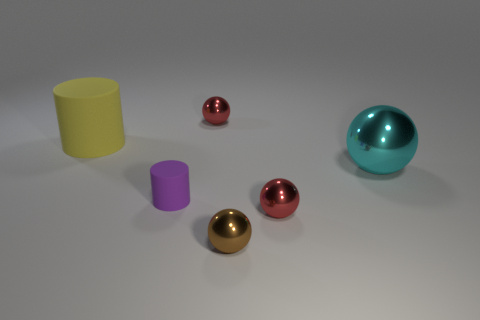How many yellow cylinders are the same size as the brown metal sphere?
Give a very brief answer. 0. There is a big thing that is on the right side of the small cylinder; does it have the same color as the small cylinder?
Ensure brevity in your answer.  No. What is the ball that is in front of the tiny rubber cylinder and on the right side of the small brown sphere made of?
Keep it short and to the point. Metal. Are there more cyan metal things than tiny metal things?
Make the answer very short. No. What is the color of the big object that is left of the tiny thing that is to the left of the tiny object that is behind the big cyan sphere?
Offer a terse response. Yellow. Does the small object behind the yellow cylinder have the same material as the brown sphere?
Make the answer very short. Yes. Is there another rubber object that has the same color as the small rubber thing?
Give a very brief answer. No. Are there any big balls?
Provide a short and direct response. Yes. Does the cylinder in front of the cyan thing have the same size as the brown thing?
Offer a terse response. Yes. Are there fewer brown shiny objects than small shiny balls?
Provide a succinct answer. Yes. 